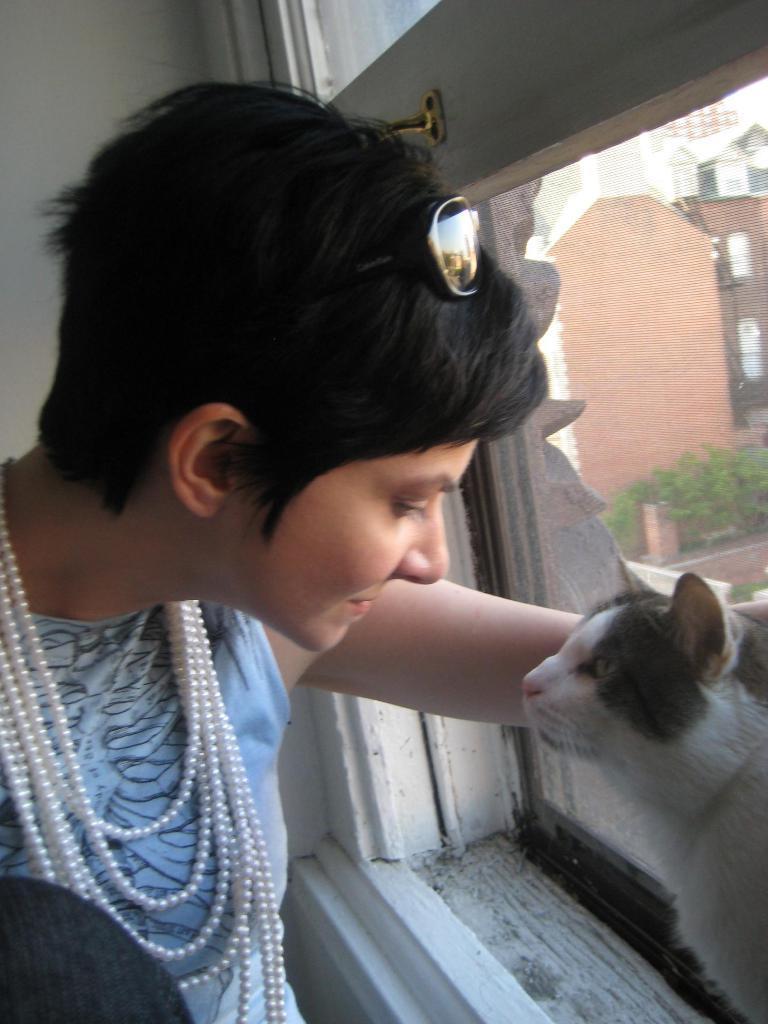In one or two sentences, can you explain what this image depicts? In this image there is a person in the foreground. There is a wall in the background. There is a cat and a glass window through which we can see buildings and trees on the right corner. 